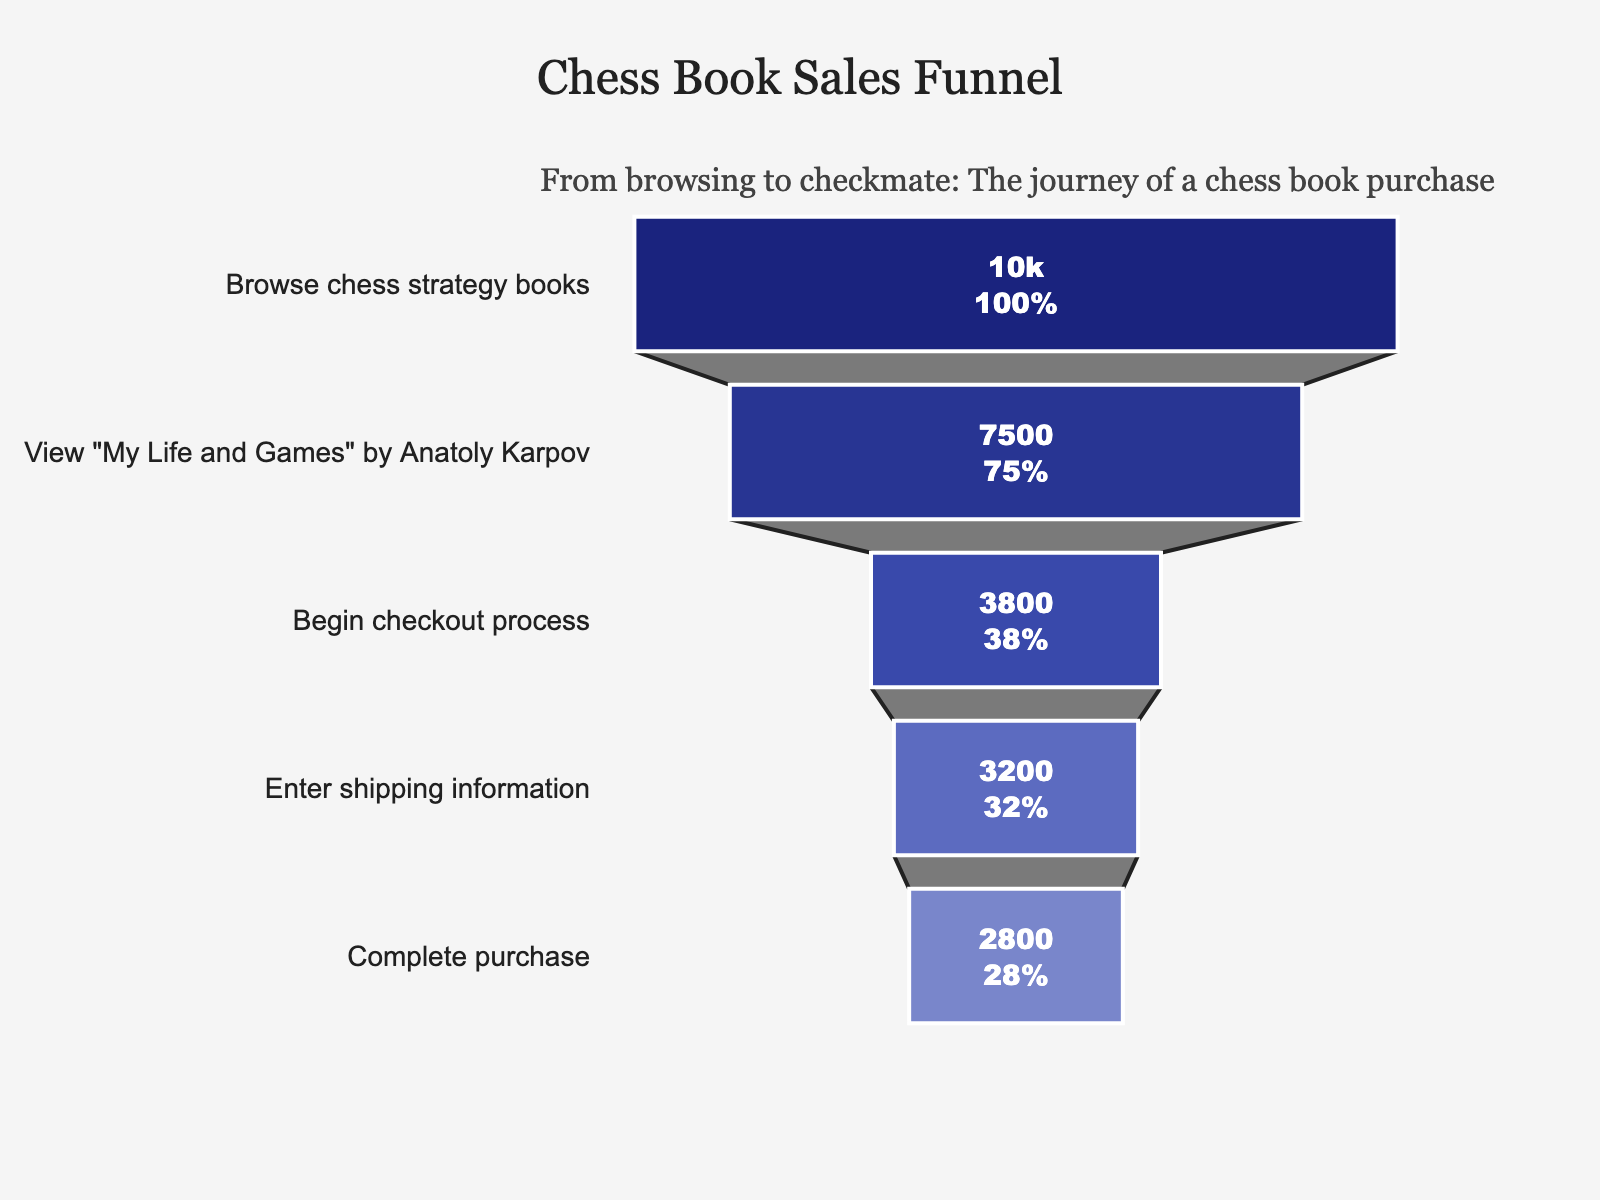How many users started by browsing chess strategy books? The first stage of the funnel indicates the number of users who initially browsed chess strategy books. This number is visually represented at the top of the funnel.
Answer: 10,000 What is the title of the funnel chart? The title is located at the top center of the figure. It summarizes the content and purpose of the chart.
Answer: Chess Book Sales Funnel By how many users does the number of people entering shipping information exceed those who completed the purchase? To find the difference, subtract the number of users who completed the purchase (2,800) from those who entered shipping information (3,200).
Answer: 400 Which stage has the most significant drop-off in users? Compare the differences between consecutive stages and identify the largest drop-off. The drop from "View 'My Life and Games' by Anatoly Karpov" (7,500) to "Begin checkout process" (3,800) is the largest.
Answer: View "My Life and Games" by Anatoly Karpov to Begin checkout process What percentage of users who viewed "My Life and Games" by Anatoly Karpov completed the purchase? Divide the number of users who completed the purchase (2,800) by the number of users who viewed "My Life and Games" (7,500) and then multiply by 100 to get the percentage.
Answer: 37.33% What color represents the "Complete purchase" stage? The color for the "Complete purchase" stage is the one at the bottom of the funnel. The colors progress from dark blue to light blue as the stages go down.
Answer: Light blue How many stages are there in the funnel chart? Count the number of distinct stages listed on the Y-axis of the funnel chart.
Answer: Five What is the percentage of users who begin the checkout process out of those who initially browse chess strategy books? Divide the number of users who begin the checkout process (3,800) by the number of users who browse chess strategy books (10,000) and then multiply by 100 to get the percentage.
Answer: 38% How does the number of users who begin the checkout process compare to those who view "My Life and Games" by Anatoly Karpov? Compare the numbers directly; 3,800 users begin the checkout process while 7,500 view "My Life and Games" by Anatoly Karpov. The former is fewer.
Answer: Fewer What is the final annotation message in the chart? Annotations are supplementary texts placed on the chart to provide additional context. This one is located above the funnel chart title.
Answer: From browsing to checkmate: The journey of a chess book purchase 